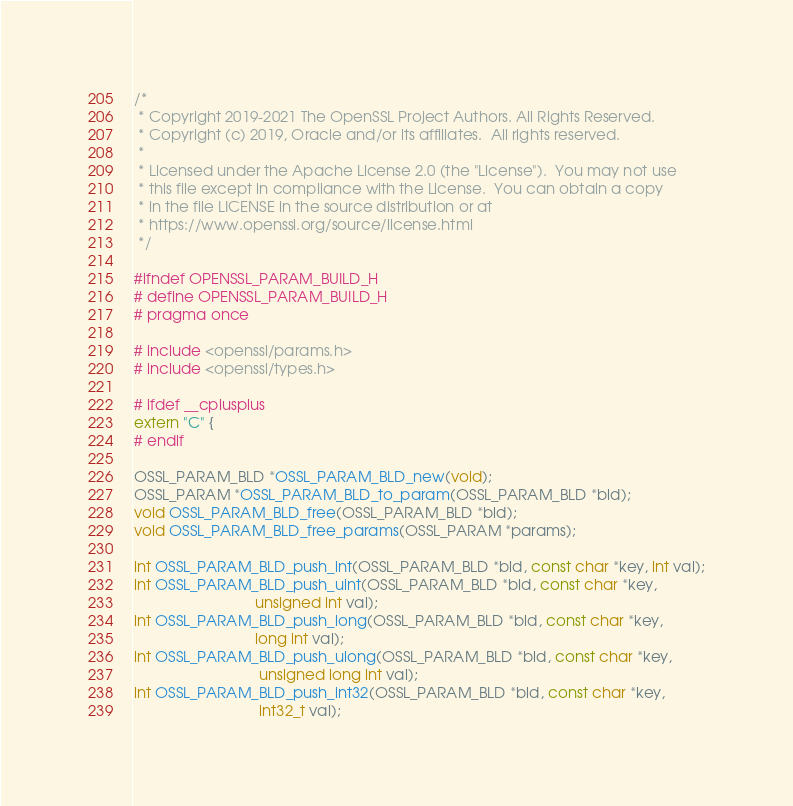<code> <loc_0><loc_0><loc_500><loc_500><_C_>/*
 * Copyright 2019-2021 The OpenSSL Project Authors. All Rights Reserved.
 * Copyright (c) 2019, Oracle and/or its affiliates.  All rights reserved.
 *
 * Licensed under the Apache License 2.0 (the "License").  You may not use
 * this file except in compliance with the License.  You can obtain a copy
 * in the file LICENSE in the source distribution or at
 * https://www.openssl.org/source/license.html
 */

#ifndef OPENSSL_PARAM_BUILD_H
# define OPENSSL_PARAM_BUILD_H
# pragma once

# include <openssl/params.h>
# include <openssl/types.h>

# ifdef __cplusplus
extern "C" {
# endif

OSSL_PARAM_BLD *OSSL_PARAM_BLD_new(void);
OSSL_PARAM *OSSL_PARAM_BLD_to_param(OSSL_PARAM_BLD *bld);
void OSSL_PARAM_BLD_free(OSSL_PARAM_BLD *bld);
void OSSL_PARAM_BLD_free_params(OSSL_PARAM *params);

int OSSL_PARAM_BLD_push_int(OSSL_PARAM_BLD *bld, const char *key, int val);
int OSSL_PARAM_BLD_push_uint(OSSL_PARAM_BLD *bld, const char *key,
                             unsigned int val);
int OSSL_PARAM_BLD_push_long(OSSL_PARAM_BLD *bld, const char *key,
                             long int val);
int OSSL_PARAM_BLD_push_ulong(OSSL_PARAM_BLD *bld, const char *key,
                              unsigned long int val);
int OSSL_PARAM_BLD_push_int32(OSSL_PARAM_BLD *bld, const char *key,
                              int32_t val);</code> 